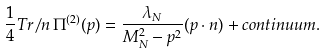<formula> <loc_0><loc_0><loc_500><loc_500>\frac { 1 } { 4 } T r { \not \, n \, } \Pi ^ { ( 2 ) } ( p ) = \frac { \lambda _ { N } } { M _ { N } ^ { 2 } - p ^ { 2 } } ( p \cdot n ) + c o n t i n u u m .</formula> 